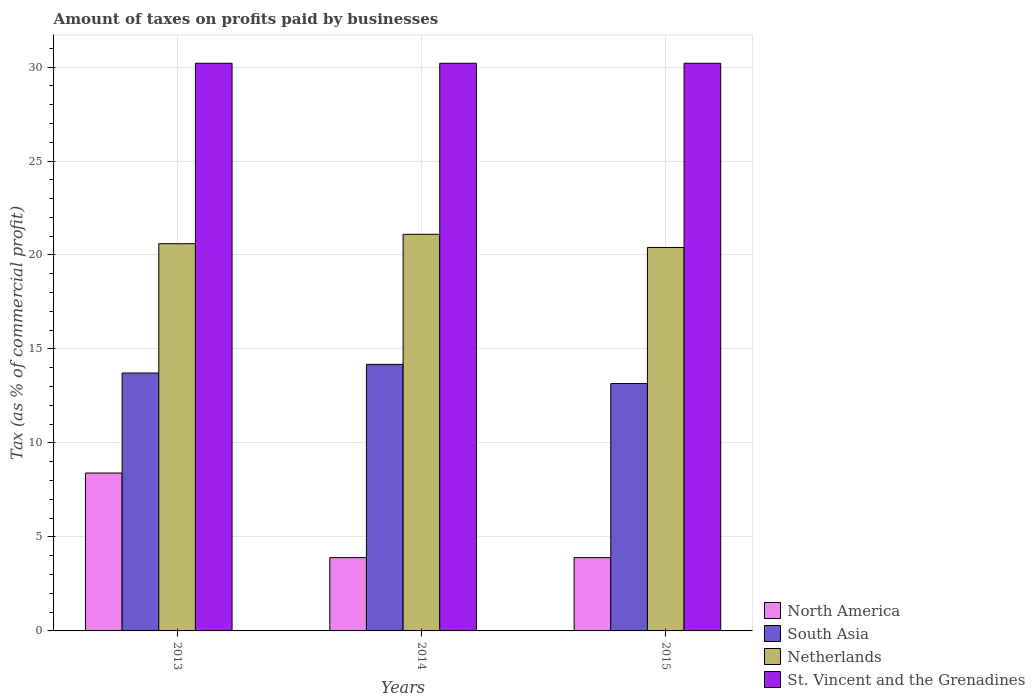Are the number of bars per tick equal to the number of legend labels?
Offer a terse response. Yes. Are the number of bars on each tick of the X-axis equal?
Offer a terse response. Yes. How many bars are there on the 1st tick from the right?
Make the answer very short. 4. What is the label of the 3rd group of bars from the left?
Ensure brevity in your answer.  2015. What is the percentage of taxes paid by businesses in South Asia in 2015?
Make the answer very short. 13.16. Across all years, what is the maximum percentage of taxes paid by businesses in North America?
Provide a succinct answer. 8.4. Across all years, what is the minimum percentage of taxes paid by businesses in St. Vincent and the Grenadines?
Give a very brief answer. 30.2. In which year was the percentage of taxes paid by businesses in Netherlands minimum?
Offer a terse response. 2015. What is the total percentage of taxes paid by businesses in South Asia in the graph?
Offer a terse response. 41.06. What is the difference between the percentage of taxes paid by businesses in South Asia in 2013 and that in 2015?
Provide a succinct answer. 0.56. What is the average percentage of taxes paid by businesses in Netherlands per year?
Keep it short and to the point. 20.7. In the year 2014, what is the difference between the percentage of taxes paid by businesses in St. Vincent and the Grenadines and percentage of taxes paid by businesses in North America?
Ensure brevity in your answer.  26.3. What is the ratio of the percentage of taxes paid by businesses in St. Vincent and the Grenadines in 2013 to that in 2014?
Make the answer very short. 1. Is the percentage of taxes paid by businesses in St. Vincent and the Grenadines in 2013 less than that in 2014?
Your answer should be compact. No. Is the difference between the percentage of taxes paid by businesses in St. Vincent and the Grenadines in 2013 and 2015 greater than the difference between the percentage of taxes paid by businesses in North America in 2013 and 2015?
Ensure brevity in your answer.  No. What is the difference between the highest and the second highest percentage of taxes paid by businesses in South Asia?
Offer a very short reply. 0.46. In how many years, is the percentage of taxes paid by businesses in St. Vincent and the Grenadines greater than the average percentage of taxes paid by businesses in St. Vincent and the Grenadines taken over all years?
Make the answer very short. 0. Is the sum of the percentage of taxes paid by businesses in North America in 2014 and 2015 greater than the maximum percentage of taxes paid by businesses in Netherlands across all years?
Keep it short and to the point. No. Is it the case that in every year, the sum of the percentage of taxes paid by businesses in St. Vincent and the Grenadines and percentage of taxes paid by businesses in North America is greater than the sum of percentage of taxes paid by businesses in South Asia and percentage of taxes paid by businesses in Netherlands?
Your answer should be compact. Yes. What does the 1st bar from the right in 2014 represents?
Your response must be concise. St. Vincent and the Grenadines. Is it the case that in every year, the sum of the percentage of taxes paid by businesses in North America and percentage of taxes paid by businesses in St. Vincent and the Grenadines is greater than the percentage of taxes paid by businesses in Netherlands?
Ensure brevity in your answer.  Yes. How many bars are there?
Offer a very short reply. 12. Are all the bars in the graph horizontal?
Ensure brevity in your answer.  No. How many years are there in the graph?
Give a very brief answer. 3. Are the values on the major ticks of Y-axis written in scientific E-notation?
Give a very brief answer. No. Does the graph contain grids?
Offer a terse response. Yes. Where does the legend appear in the graph?
Provide a succinct answer. Bottom right. What is the title of the graph?
Offer a terse response. Amount of taxes on profits paid by businesses. Does "Belgium" appear as one of the legend labels in the graph?
Your answer should be very brief. No. What is the label or title of the X-axis?
Make the answer very short. Years. What is the label or title of the Y-axis?
Offer a very short reply. Tax (as % of commercial profit). What is the Tax (as % of commercial profit) of North America in 2013?
Offer a terse response. 8.4. What is the Tax (as % of commercial profit) of South Asia in 2013?
Offer a very short reply. 13.72. What is the Tax (as % of commercial profit) of Netherlands in 2013?
Your response must be concise. 20.6. What is the Tax (as % of commercial profit) of St. Vincent and the Grenadines in 2013?
Give a very brief answer. 30.2. What is the Tax (as % of commercial profit) of North America in 2014?
Offer a very short reply. 3.9. What is the Tax (as % of commercial profit) of South Asia in 2014?
Offer a very short reply. 14.18. What is the Tax (as % of commercial profit) in Netherlands in 2014?
Ensure brevity in your answer.  21.1. What is the Tax (as % of commercial profit) of St. Vincent and the Grenadines in 2014?
Provide a short and direct response. 30.2. What is the Tax (as % of commercial profit) of North America in 2015?
Make the answer very short. 3.9. What is the Tax (as % of commercial profit) in South Asia in 2015?
Provide a succinct answer. 13.16. What is the Tax (as % of commercial profit) of Netherlands in 2015?
Offer a very short reply. 20.4. What is the Tax (as % of commercial profit) of St. Vincent and the Grenadines in 2015?
Provide a succinct answer. 30.2. Across all years, what is the maximum Tax (as % of commercial profit) of South Asia?
Give a very brief answer. 14.18. Across all years, what is the maximum Tax (as % of commercial profit) of Netherlands?
Make the answer very short. 21.1. Across all years, what is the maximum Tax (as % of commercial profit) of St. Vincent and the Grenadines?
Your response must be concise. 30.2. Across all years, what is the minimum Tax (as % of commercial profit) in North America?
Offer a very short reply. 3.9. Across all years, what is the minimum Tax (as % of commercial profit) of South Asia?
Keep it short and to the point. 13.16. Across all years, what is the minimum Tax (as % of commercial profit) of Netherlands?
Provide a succinct answer. 20.4. Across all years, what is the minimum Tax (as % of commercial profit) of St. Vincent and the Grenadines?
Provide a short and direct response. 30.2. What is the total Tax (as % of commercial profit) in North America in the graph?
Keep it short and to the point. 16.2. What is the total Tax (as % of commercial profit) in South Asia in the graph?
Offer a very short reply. 41.06. What is the total Tax (as % of commercial profit) in Netherlands in the graph?
Your answer should be very brief. 62.1. What is the total Tax (as % of commercial profit) of St. Vincent and the Grenadines in the graph?
Offer a very short reply. 90.6. What is the difference between the Tax (as % of commercial profit) in South Asia in 2013 and that in 2014?
Make the answer very short. -0.46. What is the difference between the Tax (as % of commercial profit) of South Asia in 2013 and that in 2015?
Your response must be concise. 0.56. What is the difference between the Tax (as % of commercial profit) of St. Vincent and the Grenadines in 2013 and that in 2015?
Your answer should be compact. 0. What is the difference between the Tax (as % of commercial profit) in North America in 2014 and that in 2015?
Keep it short and to the point. 0. What is the difference between the Tax (as % of commercial profit) of St. Vincent and the Grenadines in 2014 and that in 2015?
Your response must be concise. 0. What is the difference between the Tax (as % of commercial profit) in North America in 2013 and the Tax (as % of commercial profit) in South Asia in 2014?
Your answer should be very brief. -5.78. What is the difference between the Tax (as % of commercial profit) in North America in 2013 and the Tax (as % of commercial profit) in Netherlands in 2014?
Offer a terse response. -12.7. What is the difference between the Tax (as % of commercial profit) of North America in 2013 and the Tax (as % of commercial profit) of St. Vincent and the Grenadines in 2014?
Provide a succinct answer. -21.8. What is the difference between the Tax (as % of commercial profit) of South Asia in 2013 and the Tax (as % of commercial profit) of Netherlands in 2014?
Offer a terse response. -7.38. What is the difference between the Tax (as % of commercial profit) of South Asia in 2013 and the Tax (as % of commercial profit) of St. Vincent and the Grenadines in 2014?
Offer a very short reply. -16.48. What is the difference between the Tax (as % of commercial profit) in Netherlands in 2013 and the Tax (as % of commercial profit) in St. Vincent and the Grenadines in 2014?
Keep it short and to the point. -9.6. What is the difference between the Tax (as % of commercial profit) in North America in 2013 and the Tax (as % of commercial profit) in South Asia in 2015?
Your answer should be compact. -4.76. What is the difference between the Tax (as % of commercial profit) of North America in 2013 and the Tax (as % of commercial profit) of St. Vincent and the Grenadines in 2015?
Provide a succinct answer. -21.8. What is the difference between the Tax (as % of commercial profit) in South Asia in 2013 and the Tax (as % of commercial profit) in Netherlands in 2015?
Provide a short and direct response. -6.68. What is the difference between the Tax (as % of commercial profit) of South Asia in 2013 and the Tax (as % of commercial profit) of St. Vincent and the Grenadines in 2015?
Your answer should be compact. -16.48. What is the difference between the Tax (as % of commercial profit) in Netherlands in 2013 and the Tax (as % of commercial profit) in St. Vincent and the Grenadines in 2015?
Make the answer very short. -9.6. What is the difference between the Tax (as % of commercial profit) of North America in 2014 and the Tax (as % of commercial profit) of South Asia in 2015?
Your response must be concise. -9.26. What is the difference between the Tax (as % of commercial profit) of North America in 2014 and the Tax (as % of commercial profit) of Netherlands in 2015?
Provide a short and direct response. -16.5. What is the difference between the Tax (as % of commercial profit) in North America in 2014 and the Tax (as % of commercial profit) in St. Vincent and the Grenadines in 2015?
Offer a very short reply. -26.3. What is the difference between the Tax (as % of commercial profit) of South Asia in 2014 and the Tax (as % of commercial profit) of Netherlands in 2015?
Keep it short and to the point. -6.22. What is the difference between the Tax (as % of commercial profit) in South Asia in 2014 and the Tax (as % of commercial profit) in St. Vincent and the Grenadines in 2015?
Your answer should be compact. -16.02. What is the average Tax (as % of commercial profit) in North America per year?
Offer a very short reply. 5.4. What is the average Tax (as % of commercial profit) of South Asia per year?
Make the answer very short. 13.69. What is the average Tax (as % of commercial profit) of Netherlands per year?
Your response must be concise. 20.7. What is the average Tax (as % of commercial profit) of St. Vincent and the Grenadines per year?
Make the answer very short. 30.2. In the year 2013, what is the difference between the Tax (as % of commercial profit) in North America and Tax (as % of commercial profit) in South Asia?
Give a very brief answer. -5.32. In the year 2013, what is the difference between the Tax (as % of commercial profit) in North America and Tax (as % of commercial profit) in Netherlands?
Make the answer very short. -12.2. In the year 2013, what is the difference between the Tax (as % of commercial profit) in North America and Tax (as % of commercial profit) in St. Vincent and the Grenadines?
Your response must be concise. -21.8. In the year 2013, what is the difference between the Tax (as % of commercial profit) of South Asia and Tax (as % of commercial profit) of Netherlands?
Ensure brevity in your answer.  -6.88. In the year 2013, what is the difference between the Tax (as % of commercial profit) of South Asia and Tax (as % of commercial profit) of St. Vincent and the Grenadines?
Provide a short and direct response. -16.48. In the year 2013, what is the difference between the Tax (as % of commercial profit) in Netherlands and Tax (as % of commercial profit) in St. Vincent and the Grenadines?
Provide a succinct answer. -9.6. In the year 2014, what is the difference between the Tax (as % of commercial profit) of North America and Tax (as % of commercial profit) of South Asia?
Provide a succinct answer. -10.28. In the year 2014, what is the difference between the Tax (as % of commercial profit) of North America and Tax (as % of commercial profit) of Netherlands?
Offer a very short reply. -17.2. In the year 2014, what is the difference between the Tax (as % of commercial profit) of North America and Tax (as % of commercial profit) of St. Vincent and the Grenadines?
Your answer should be very brief. -26.3. In the year 2014, what is the difference between the Tax (as % of commercial profit) of South Asia and Tax (as % of commercial profit) of Netherlands?
Ensure brevity in your answer.  -6.92. In the year 2014, what is the difference between the Tax (as % of commercial profit) of South Asia and Tax (as % of commercial profit) of St. Vincent and the Grenadines?
Offer a very short reply. -16.02. In the year 2015, what is the difference between the Tax (as % of commercial profit) in North America and Tax (as % of commercial profit) in South Asia?
Make the answer very short. -9.26. In the year 2015, what is the difference between the Tax (as % of commercial profit) in North America and Tax (as % of commercial profit) in Netherlands?
Give a very brief answer. -16.5. In the year 2015, what is the difference between the Tax (as % of commercial profit) of North America and Tax (as % of commercial profit) of St. Vincent and the Grenadines?
Offer a very short reply. -26.3. In the year 2015, what is the difference between the Tax (as % of commercial profit) of South Asia and Tax (as % of commercial profit) of Netherlands?
Keep it short and to the point. -7.24. In the year 2015, what is the difference between the Tax (as % of commercial profit) in South Asia and Tax (as % of commercial profit) in St. Vincent and the Grenadines?
Make the answer very short. -17.04. In the year 2015, what is the difference between the Tax (as % of commercial profit) in Netherlands and Tax (as % of commercial profit) in St. Vincent and the Grenadines?
Provide a short and direct response. -9.8. What is the ratio of the Tax (as % of commercial profit) in North America in 2013 to that in 2014?
Ensure brevity in your answer.  2.15. What is the ratio of the Tax (as % of commercial profit) in South Asia in 2013 to that in 2014?
Provide a succinct answer. 0.97. What is the ratio of the Tax (as % of commercial profit) of Netherlands in 2013 to that in 2014?
Offer a very short reply. 0.98. What is the ratio of the Tax (as % of commercial profit) in North America in 2013 to that in 2015?
Your answer should be compact. 2.15. What is the ratio of the Tax (as % of commercial profit) of South Asia in 2013 to that in 2015?
Offer a very short reply. 1.04. What is the ratio of the Tax (as % of commercial profit) of Netherlands in 2013 to that in 2015?
Make the answer very short. 1.01. What is the ratio of the Tax (as % of commercial profit) in St. Vincent and the Grenadines in 2013 to that in 2015?
Keep it short and to the point. 1. What is the ratio of the Tax (as % of commercial profit) of North America in 2014 to that in 2015?
Ensure brevity in your answer.  1. What is the ratio of the Tax (as % of commercial profit) in South Asia in 2014 to that in 2015?
Provide a succinct answer. 1.08. What is the ratio of the Tax (as % of commercial profit) in Netherlands in 2014 to that in 2015?
Your answer should be very brief. 1.03. What is the ratio of the Tax (as % of commercial profit) of St. Vincent and the Grenadines in 2014 to that in 2015?
Your answer should be compact. 1. What is the difference between the highest and the second highest Tax (as % of commercial profit) in South Asia?
Provide a short and direct response. 0.46. What is the difference between the highest and the second highest Tax (as % of commercial profit) of Netherlands?
Give a very brief answer. 0.5. What is the difference between the highest and the second highest Tax (as % of commercial profit) in St. Vincent and the Grenadines?
Offer a very short reply. 0. What is the difference between the highest and the lowest Tax (as % of commercial profit) of North America?
Give a very brief answer. 4.5. What is the difference between the highest and the lowest Tax (as % of commercial profit) in South Asia?
Offer a very short reply. 1.02. What is the difference between the highest and the lowest Tax (as % of commercial profit) in Netherlands?
Keep it short and to the point. 0.7. What is the difference between the highest and the lowest Tax (as % of commercial profit) in St. Vincent and the Grenadines?
Provide a short and direct response. 0. 